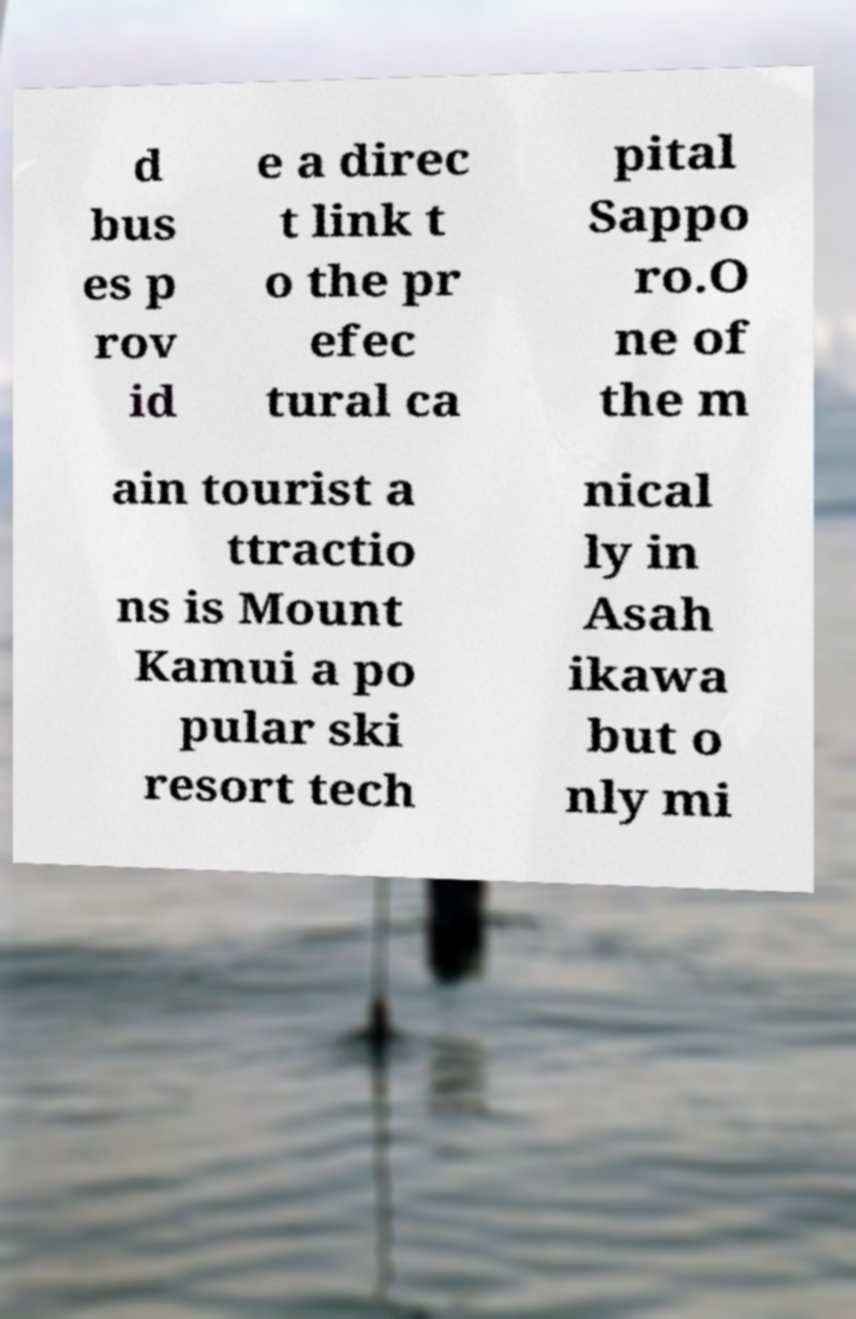Please read and relay the text visible in this image. What does it say? d bus es p rov id e a direc t link t o the pr efec tural ca pital Sappo ro.O ne of the m ain tourist a ttractio ns is Mount Kamui a po pular ski resort tech nical ly in Asah ikawa but o nly mi 